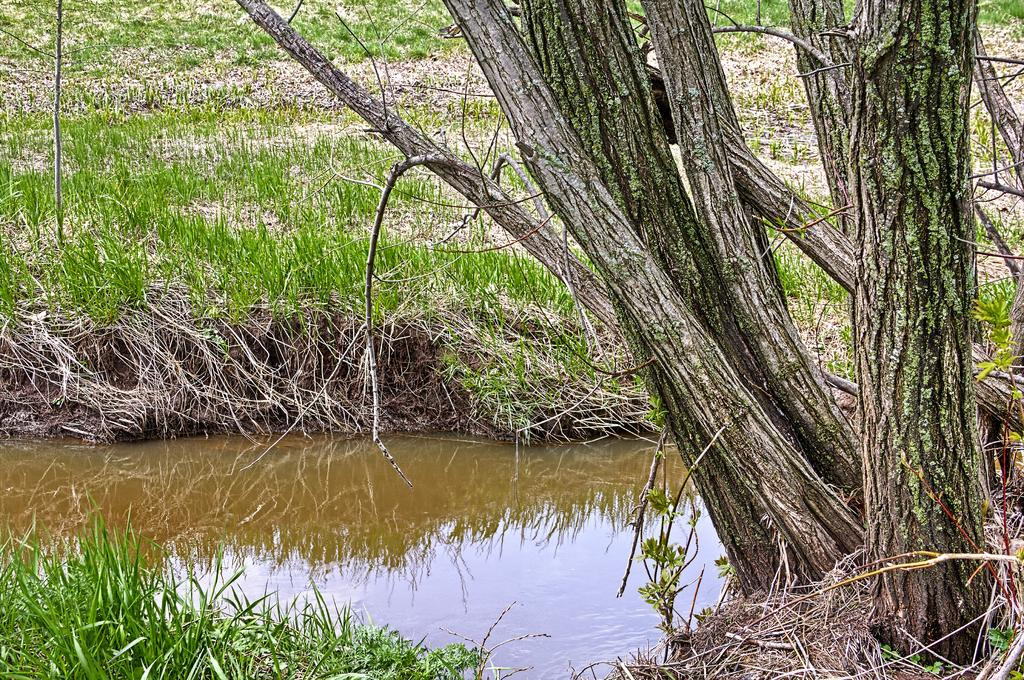What is the primary element visible in the picture? There is water in the picture. What type of vegetation can be seen in the picture? There is grass in the picture. Are there any structures or objects made of wood in the picture? There are tree trunks in the picture. How many pigs can be seen drawing with a crayon near the volcano in the image? There are no pigs, crayons, or volcanoes present in the image. 